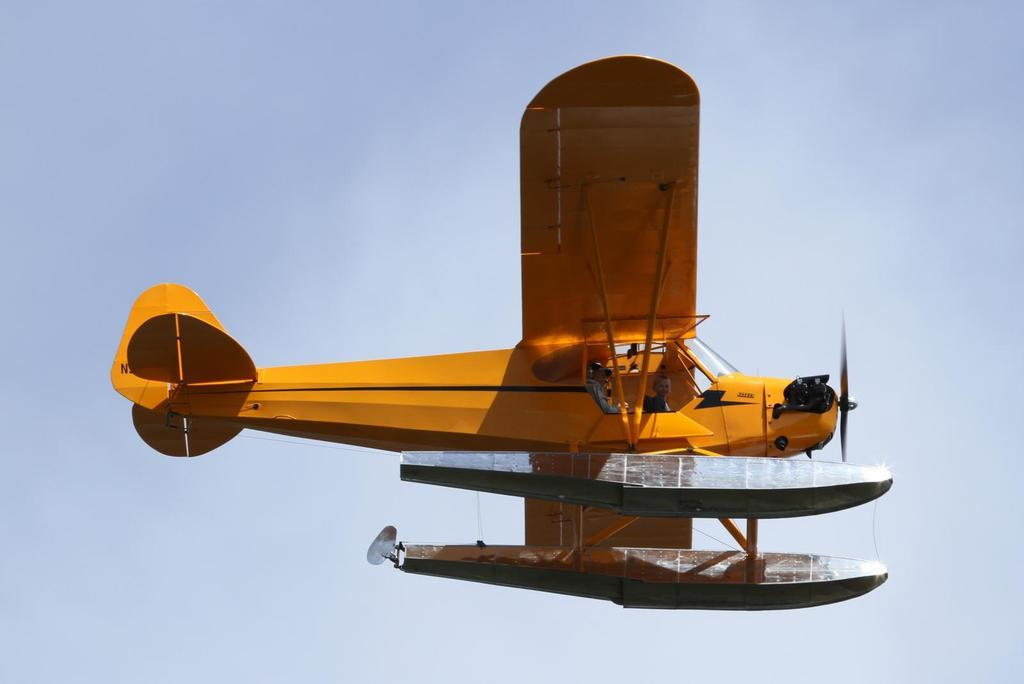What is the main subject of the image? The main subject of the image is an airplane. What can be seen in the background of the image? The sky is visible in the background of the image. What type of produce is being sold on the sidewalk in the image? There is no produce or sidewalk present in the image; it features an airplane and the sky. What ingredients are used to make the stew in the image? There is no stew present in the image; it features an airplane and the sky. 